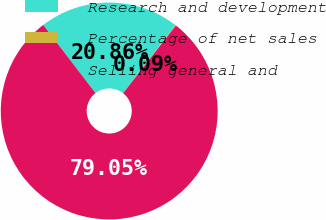<chart> <loc_0><loc_0><loc_500><loc_500><pie_chart><fcel>Research and development<fcel>Percentage of net sales<fcel>Selling general and<nl><fcel>20.86%<fcel>0.09%<fcel>79.05%<nl></chart> 